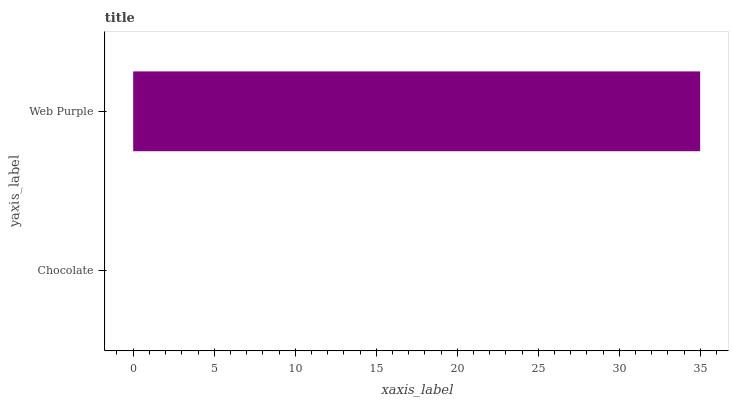Is Chocolate the minimum?
Answer yes or no. Yes. Is Web Purple the maximum?
Answer yes or no. Yes. Is Web Purple the minimum?
Answer yes or no. No. Is Web Purple greater than Chocolate?
Answer yes or no. Yes. Is Chocolate less than Web Purple?
Answer yes or no. Yes. Is Chocolate greater than Web Purple?
Answer yes or no. No. Is Web Purple less than Chocolate?
Answer yes or no. No. Is Web Purple the high median?
Answer yes or no. Yes. Is Chocolate the low median?
Answer yes or no. Yes. Is Chocolate the high median?
Answer yes or no. No. Is Web Purple the low median?
Answer yes or no. No. 